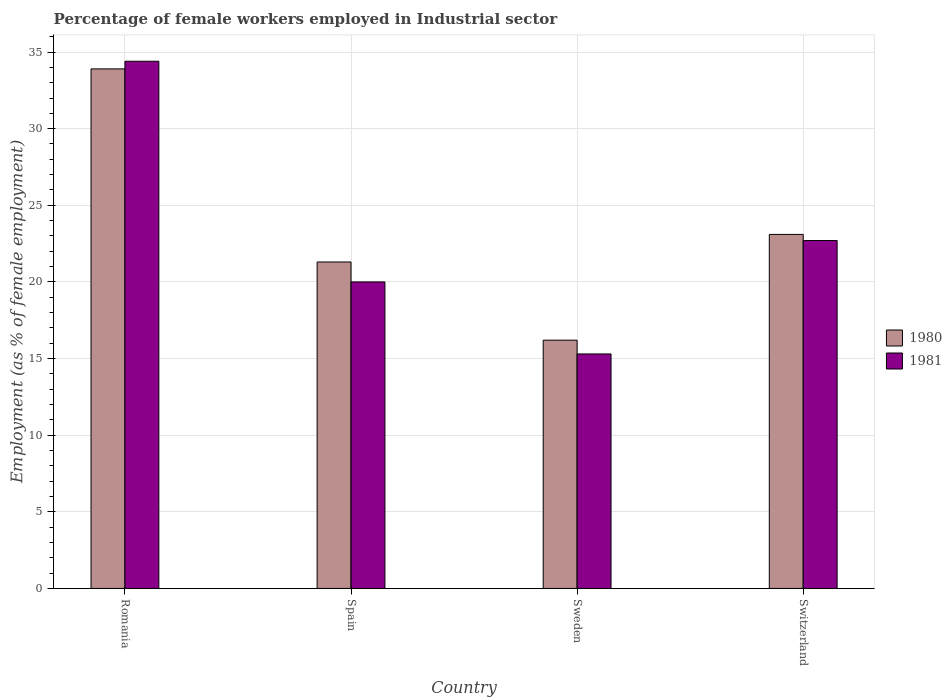How many groups of bars are there?
Provide a succinct answer. 4. Are the number of bars per tick equal to the number of legend labels?
Give a very brief answer. Yes. How many bars are there on the 1st tick from the right?
Make the answer very short. 2. What is the label of the 4th group of bars from the left?
Your response must be concise. Switzerland. What is the percentage of females employed in Industrial sector in 1980 in Switzerland?
Ensure brevity in your answer.  23.1. Across all countries, what is the maximum percentage of females employed in Industrial sector in 1981?
Provide a short and direct response. 34.4. Across all countries, what is the minimum percentage of females employed in Industrial sector in 1980?
Provide a short and direct response. 16.2. In which country was the percentage of females employed in Industrial sector in 1981 maximum?
Your answer should be compact. Romania. What is the total percentage of females employed in Industrial sector in 1981 in the graph?
Your answer should be very brief. 92.4. What is the difference between the percentage of females employed in Industrial sector in 1981 in Sweden and that in Switzerland?
Your response must be concise. -7.4. What is the difference between the percentage of females employed in Industrial sector in 1981 in Sweden and the percentage of females employed in Industrial sector in 1980 in Spain?
Ensure brevity in your answer.  -6. What is the average percentage of females employed in Industrial sector in 1981 per country?
Give a very brief answer. 23.1. What is the difference between the percentage of females employed in Industrial sector of/in 1981 and percentage of females employed in Industrial sector of/in 1980 in Spain?
Offer a terse response. -1.3. In how many countries, is the percentage of females employed in Industrial sector in 1981 greater than 32 %?
Give a very brief answer. 1. What is the ratio of the percentage of females employed in Industrial sector in 1980 in Sweden to that in Switzerland?
Your answer should be compact. 0.7. What is the difference between the highest and the second highest percentage of females employed in Industrial sector in 1981?
Provide a short and direct response. 14.4. What is the difference between the highest and the lowest percentage of females employed in Industrial sector in 1980?
Give a very brief answer. 17.7. Is the sum of the percentage of females employed in Industrial sector in 1981 in Romania and Spain greater than the maximum percentage of females employed in Industrial sector in 1980 across all countries?
Offer a very short reply. Yes. What does the 1st bar from the left in Switzerland represents?
Ensure brevity in your answer.  1980. What does the 2nd bar from the right in Switzerland represents?
Provide a short and direct response. 1980. How many bars are there?
Provide a succinct answer. 8. Are all the bars in the graph horizontal?
Offer a very short reply. No. How many countries are there in the graph?
Give a very brief answer. 4. Does the graph contain any zero values?
Provide a succinct answer. No. Does the graph contain grids?
Ensure brevity in your answer.  Yes. What is the title of the graph?
Keep it short and to the point. Percentage of female workers employed in Industrial sector. Does "1975" appear as one of the legend labels in the graph?
Your answer should be compact. No. What is the label or title of the X-axis?
Give a very brief answer. Country. What is the label or title of the Y-axis?
Ensure brevity in your answer.  Employment (as % of female employment). What is the Employment (as % of female employment) in 1980 in Romania?
Make the answer very short. 33.9. What is the Employment (as % of female employment) in 1981 in Romania?
Keep it short and to the point. 34.4. What is the Employment (as % of female employment) of 1980 in Spain?
Your response must be concise. 21.3. What is the Employment (as % of female employment) of 1981 in Spain?
Your answer should be compact. 20. What is the Employment (as % of female employment) in 1980 in Sweden?
Ensure brevity in your answer.  16.2. What is the Employment (as % of female employment) in 1981 in Sweden?
Your answer should be compact. 15.3. What is the Employment (as % of female employment) of 1980 in Switzerland?
Offer a terse response. 23.1. What is the Employment (as % of female employment) of 1981 in Switzerland?
Provide a succinct answer. 22.7. Across all countries, what is the maximum Employment (as % of female employment) of 1980?
Make the answer very short. 33.9. Across all countries, what is the maximum Employment (as % of female employment) of 1981?
Your response must be concise. 34.4. Across all countries, what is the minimum Employment (as % of female employment) in 1980?
Give a very brief answer. 16.2. Across all countries, what is the minimum Employment (as % of female employment) of 1981?
Give a very brief answer. 15.3. What is the total Employment (as % of female employment) of 1980 in the graph?
Your answer should be very brief. 94.5. What is the total Employment (as % of female employment) in 1981 in the graph?
Provide a succinct answer. 92.4. What is the difference between the Employment (as % of female employment) in 1980 in Romania and that in Spain?
Provide a short and direct response. 12.6. What is the difference between the Employment (as % of female employment) in 1980 in Romania and that in Switzerland?
Offer a terse response. 10.8. What is the difference between the Employment (as % of female employment) of 1981 in Romania and that in Switzerland?
Provide a succinct answer. 11.7. What is the difference between the Employment (as % of female employment) in 1981 in Spain and that in Sweden?
Offer a very short reply. 4.7. What is the difference between the Employment (as % of female employment) of 1980 in Spain and that in Switzerland?
Keep it short and to the point. -1.8. What is the difference between the Employment (as % of female employment) in 1981 in Spain and that in Switzerland?
Give a very brief answer. -2.7. What is the difference between the Employment (as % of female employment) of 1981 in Sweden and that in Switzerland?
Offer a terse response. -7.4. What is the difference between the Employment (as % of female employment) in 1980 in Romania and the Employment (as % of female employment) in 1981 in Spain?
Give a very brief answer. 13.9. What is the difference between the Employment (as % of female employment) of 1980 in Romania and the Employment (as % of female employment) of 1981 in Switzerland?
Keep it short and to the point. 11.2. What is the difference between the Employment (as % of female employment) of 1980 in Spain and the Employment (as % of female employment) of 1981 in Sweden?
Offer a terse response. 6. What is the difference between the Employment (as % of female employment) of 1980 in Spain and the Employment (as % of female employment) of 1981 in Switzerland?
Your answer should be compact. -1.4. What is the difference between the Employment (as % of female employment) of 1980 in Sweden and the Employment (as % of female employment) of 1981 in Switzerland?
Keep it short and to the point. -6.5. What is the average Employment (as % of female employment) in 1980 per country?
Offer a terse response. 23.62. What is the average Employment (as % of female employment) in 1981 per country?
Make the answer very short. 23.1. What is the difference between the Employment (as % of female employment) of 1980 and Employment (as % of female employment) of 1981 in Romania?
Your answer should be compact. -0.5. What is the difference between the Employment (as % of female employment) of 1980 and Employment (as % of female employment) of 1981 in Spain?
Offer a terse response. 1.3. What is the difference between the Employment (as % of female employment) of 1980 and Employment (as % of female employment) of 1981 in Sweden?
Your answer should be compact. 0.9. What is the ratio of the Employment (as % of female employment) of 1980 in Romania to that in Spain?
Give a very brief answer. 1.59. What is the ratio of the Employment (as % of female employment) of 1981 in Romania to that in Spain?
Make the answer very short. 1.72. What is the ratio of the Employment (as % of female employment) in 1980 in Romania to that in Sweden?
Your answer should be compact. 2.09. What is the ratio of the Employment (as % of female employment) of 1981 in Romania to that in Sweden?
Your answer should be compact. 2.25. What is the ratio of the Employment (as % of female employment) in 1980 in Romania to that in Switzerland?
Give a very brief answer. 1.47. What is the ratio of the Employment (as % of female employment) of 1981 in Romania to that in Switzerland?
Give a very brief answer. 1.52. What is the ratio of the Employment (as % of female employment) in 1980 in Spain to that in Sweden?
Your response must be concise. 1.31. What is the ratio of the Employment (as % of female employment) in 1981 in Spain to that in Sweden?
Provide a succinct answer. 1.31. What is the ratio of the Employment (as % of female employment) of 1980 in Spain to that in Switzerland?
Make the answer very short. 0.92. What is the ratio of the Employment (as % of female employment) in 1981 in Spain to that in Switzerland?
Your answer should be very brief. 0.88. What is the ratio of the Employment (as % of female employment) in 1980 in Sweden to that in Switzerland?
Offer a terse response. 0.7. What is the ratio of the Employment (as % of female employment) of 1981 in Sweden to that in Switzerland?
Provide a succinct answer. 0.67. What is the difference between the highest and the lowest Employment (as % of female employment) of 1981?
Your answer should be compact. 19.1. 